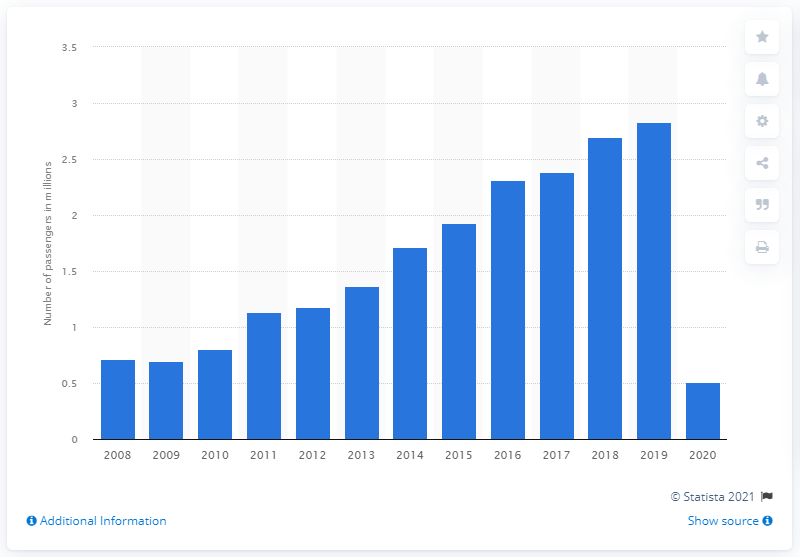Give some essential details in this illustration. The number of passengers declined in 2020 to 0.51 as a result of the COVID-19 pandemic. 